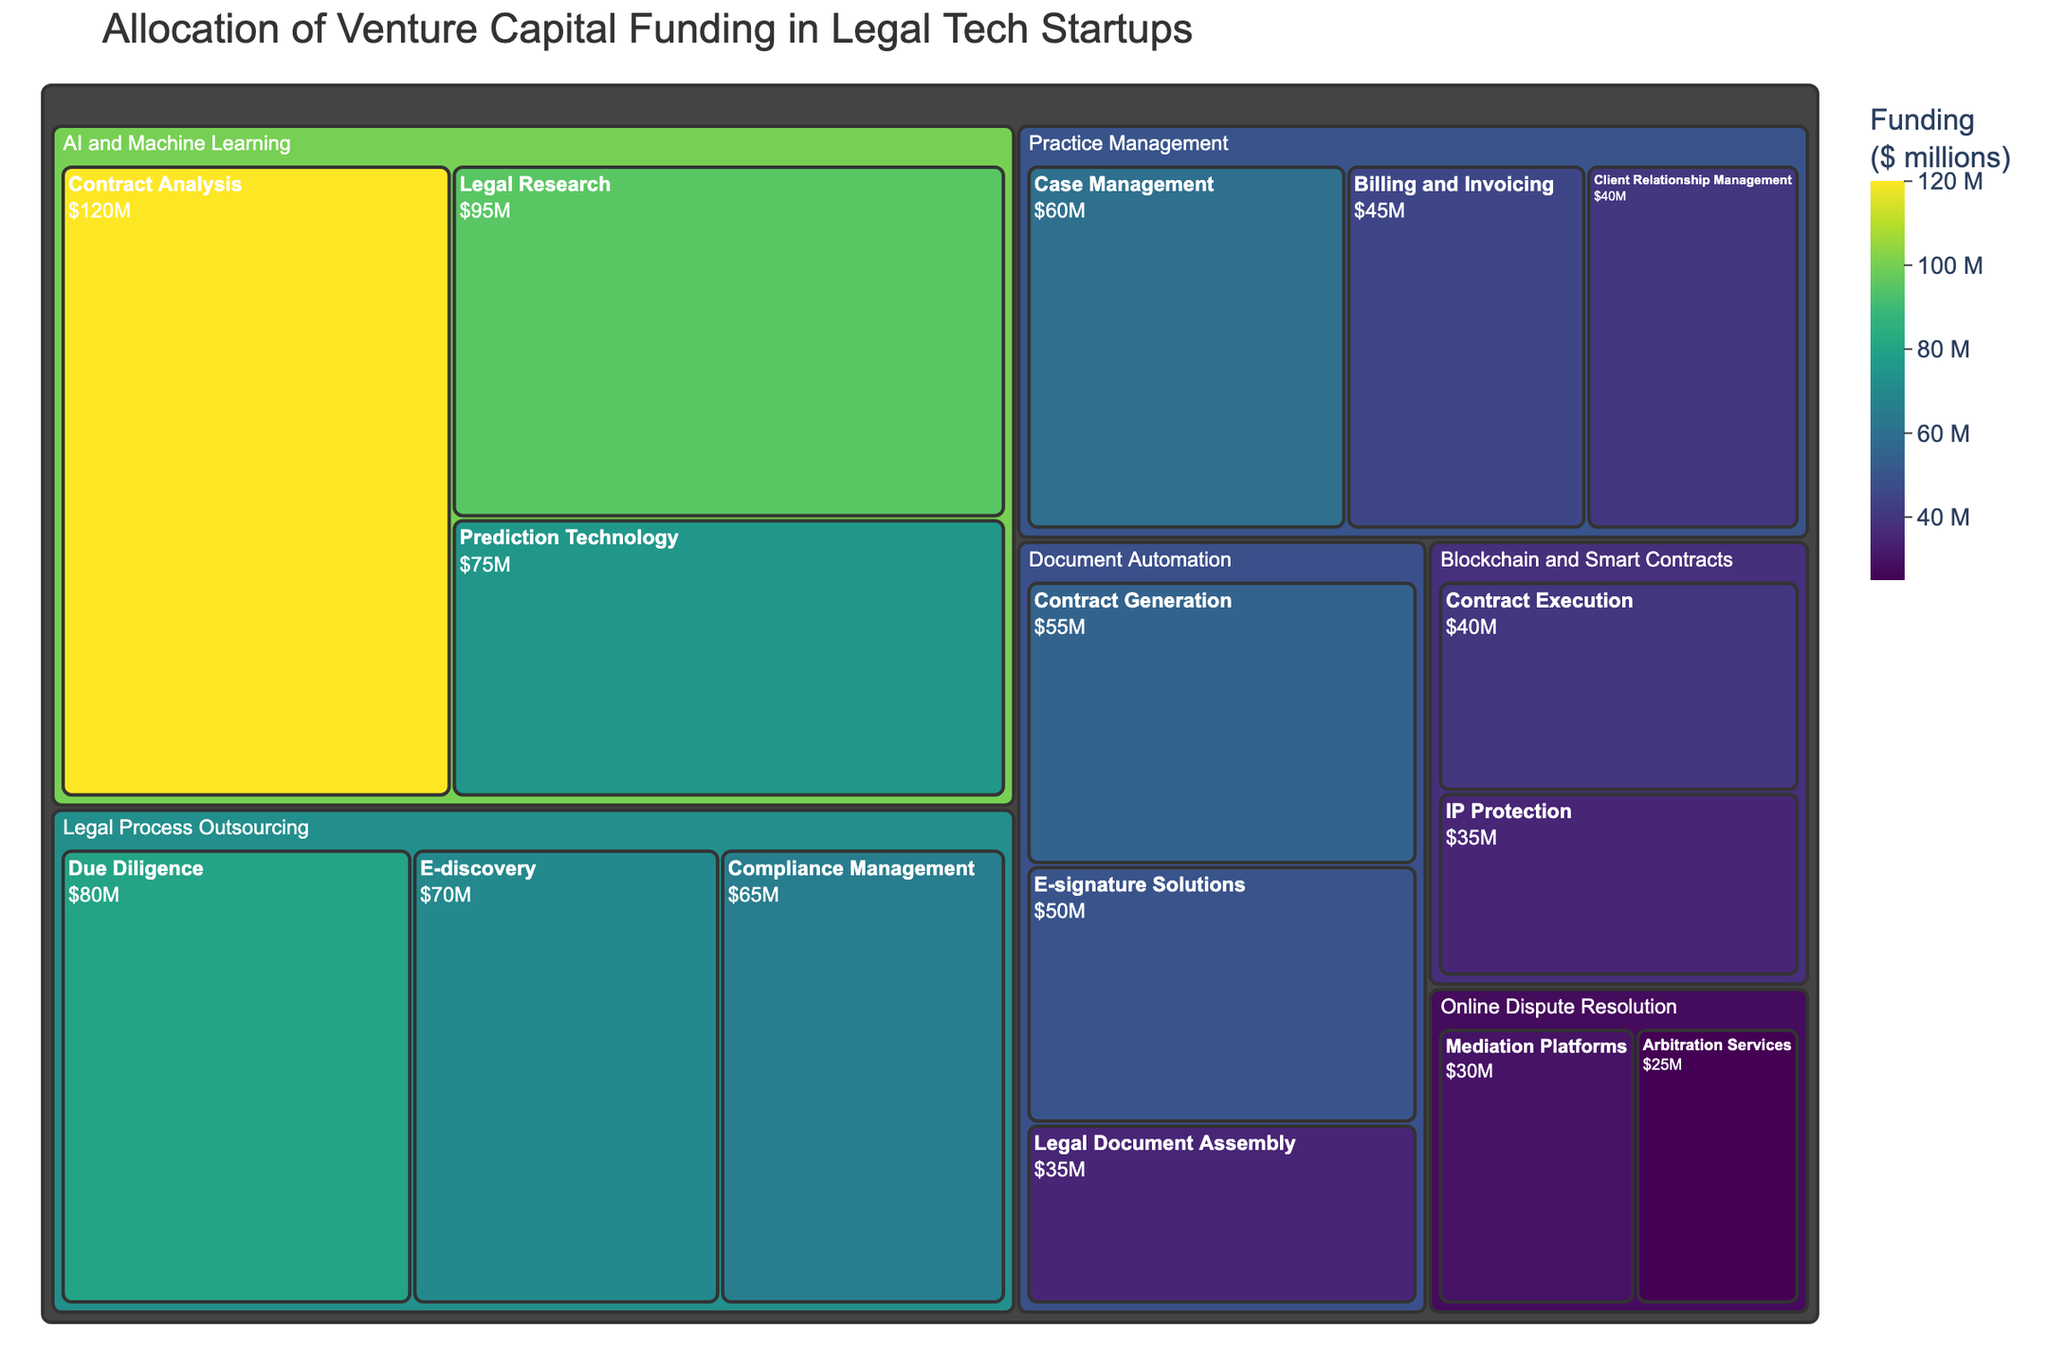What's the title of the Treemap? The title is usually displayed at the top of the treemap and summarizes the main insight.
Answer: Allocation of Venture Capital Funding in Legal Tech Startups Which subcategory under AI and Machine Learning received the most funding? In the AI and Machine Learning category, compare the funding amounts of Contract Analysis, Legal Research, and Prediction Technology. Identify the highest value.
Answer: Contract Analysis What is the total funding for the Practice Management category? Add the values for the subcategories within Practice Management: Case Management, Billing and Invoicing, and Client Relationship Management. 60 + 45 + 40 = 145
Answer: 145 million dollars Which category has the least total funding? Compare the total sum of subcategory funding for each major category. Identify the category with the smallest sum.
Answer: Online Dispute Resolution How much funding did Compliance Management receive compared to Legal Research? Look at the funding values for Compliance Management and Legal Research. Compare these values directly.
Answer: Compliance Management received 65 million dollars, Legal Research received 95 million dollars What is the average funding amount for subcategories within Document Automation? Add the values of Contract Generation, E-signature Solutions, and Legal Document Assembly, then divide by 3. (55 + 50 + 35) / 3 = 140 / 3
Answer: Approximately 46.67 million dollars Which subcategory received the least funding? Identify the subcategory with the lowest funding amount across all categories and subcategories.
Answer: Arbitration Services How much more funding did Due Diligence receive than Mediation Platforms? Subtract the funding amount for Mediation Platforms from Due Diligence. 80 - 30 = 50
Answer: 50 million dollars Arrange the categories in descending order by their total funding. Calculate the total funding for each category and list them from highest to lowest total funding: AI and Machine Learning, Practice Management, Legal Process Outsourcing, Document Automation, Blockchain and Smart Contracts, Online Dispute Resolution.
Answer: AI and Machine Learning, Practice Management, Legal Process Outsourcing, Document Automation, Blockchain and Smart Contracts, Online Dispute Resolution 